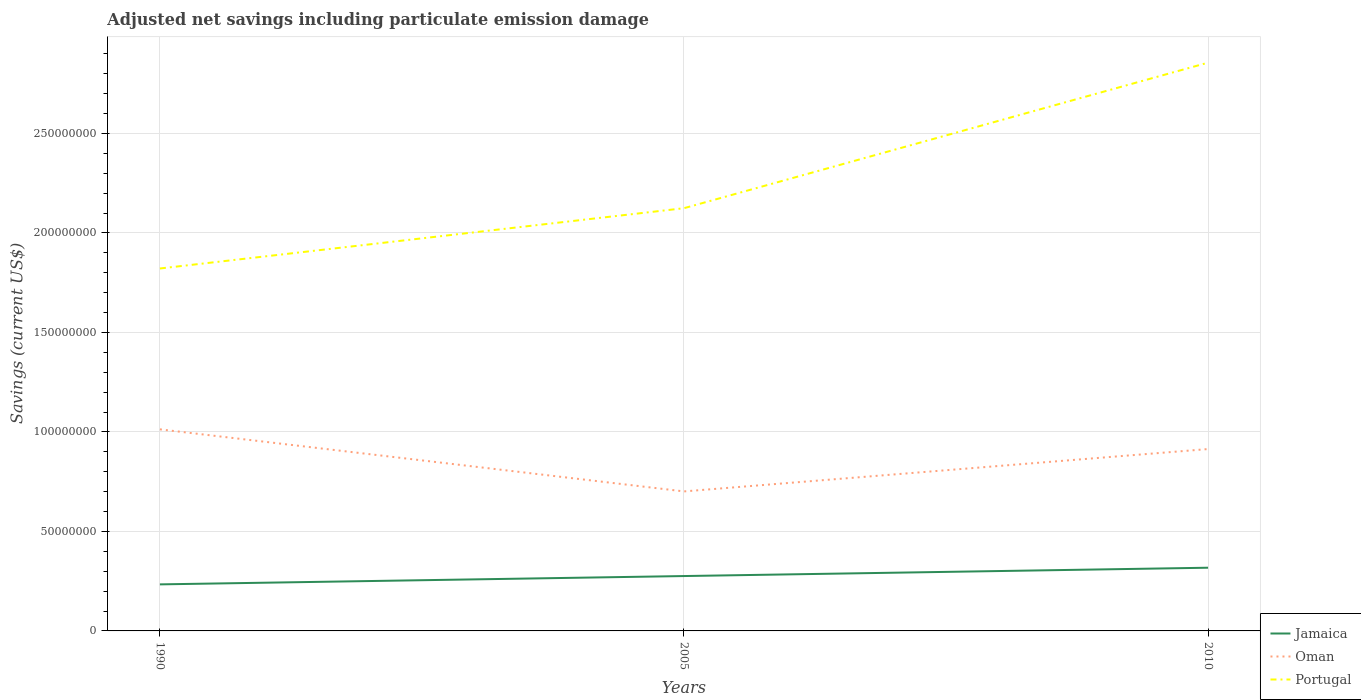Is the number of lines equal to the number of legend labels?
Make the answer very short. Yes. Across all years, what is the maximum net savings in Portugal?
Your response must be concise. 1.82e+08. What is the total net savings in Oman in the graph?
Offer a terse response. -2.13e+07. What is the difference between the highest and the second highest net savings in Jamaica?
Give a very brief answer. 8.37e+06. What is the difference between the highest and the lowest net savings in Jamaica?
Offer a terse response. 1. Is the net savings in Oman strictly greater than the net savings in Jamaica over the years?
Your response must be concise. No. How many lines are there?
Provide a succinct answer. 3. What is the difference between two consecutive major ticks on the Y-axis?
Your answer should be very brief. 5.00e+07. Are the values on the major ticks of Y-axis written in scientific E-notation?
Offer a very short reply. No. Does the graph contain grids?
Offer a terse response. Yes. How many legend labels are there?
Make the answer very short. 3. How are the legend labels stacked?
Your response must be concise. Vertical. What is the title of the graph?
Make the answer very short. Adjusted net savings including particulate emission damage. Does "Iraq" appear as one of the legend labels in the graph?
Your answer should be very brief. No. What is the label or title of the Y-axis?
Provide a short and direct response. Savings (current US$). What is the Savings (current US$) of Jamaica in 1990?
Ensure brevity in your answer.  2.34e+07. What is the Savings (current US$) in Oman in 1990?
Your answer should be very brief. 1.01e+08. What is the Savings (current US$) of Portugal in 1990?
Offer a very short reply. 1.82e+08. What is the Savings (current US$) in Jamaica in 2005?
Make the answer very short. 2.76e+07. What is the Savings (current US$) of Oman in 2005?
Offer a very short reply. 7.01e+07. What is the Savings (current US$) in Portugal in 2005?
Provide a succinct answer. 2.12e+08. What is the Savings (current US$) of Jamaica in 2010?
Give a very brief answer. 3.18e+07. What is the Savings (current US$) in Oman in 2010?
Make the answer very short. 9.14e+07. What is the Savings (current US$) in Portugal in 2010?
Your answer should be very brief. 2.86e+08. Across all years, what is the maximum Savings (current US$) in Jamaica?
Offer a terse response. 3.18e+07. Across all years, what is the maximum Savings (current US$) in Oman?
Your answer should be very brief. 1.01e+08. Across all years, what is the maximum Savings (current US$) of Portugal?
Your answer should be compact. 2.86e+08. Across all years, what is the minimum Savings (current US$) of Jamaica?
Offer a terse response. 2.34e+07. Across all years, what is the minimum Savings (current US$) in Oman?
Provide a succinct answer. 7.01e+07. Across all years, what is the minimum Savings (current US$) of Portugal?
Offer a very short reply. 1.82e+08. What is the total Savings (current US$) in Jamaica in the graph?
Provide a short and direct response. 8.27e+07. What is the total Savings (current US$) of Oman in the graph?
Provide a short and direct response. 2.63e+08. What is the total Savings (current US$) of Portugal in the graph?
Make the answer very short. 6.80e+08. What is the difference between the Savings (current US$) in Jamaica in 1990 and that in 2005?
Your response must be concise. -4.18e+06. What is the difference between the Savings (current US$) in Oman in 1990 and that in 2005?
Keep it short and to the point. 3.12e+07. What is the difference between the Savings (current US$) in Portugal in 1990 and that in 2005?
Your answer should be compact. -3.03e+07. What is the difference between the Savings (current US$) in Jamaica in 1990 and that in 2010?
Give a very brief answer. -8.37e+06. What is the difference between the Savings (current US$) of Oman in 1990 and that in 2010?
Your answer should be compact. 9.91e+06. What is the difference between the Savings (current US$) in Portugal in 1990 and that in 2010?
Give a very brief answer. -1.03e+08. What is the difference between the Savings (current US$) of Jamaica in 2005 and that in 2010?
Your response must be concise. -4.19e+06. What is the difference between the Savings (current US$) of Oman in 2005 and that in 2010?
Provide a short and direct response. -2.13e+07. What is the difference between the Savings (current US$) in Portugal in 2005 and that in 2010?
Provide a succinct answer. -7.31e+07. What is the difference between the Savings (current US$) of Jamaica in 1990 and the Savings (current US$) of Oman in 2005?
Keep it short and to the point. -4.67e+07. What is the difference between the Savings (current US$) of Jamaica in 1990 and the Savings (current US$) of Portugal in 2005?
Offer a very short reply. -1.89e+08. What is the difference between the Savings (current US$) in Oman in 1990 and the Savings (current US$) in Portugal in 2005?
Make the answer very short. -1.11e+08. What is the difference between the Savings (current US$) in Jamaica in 1990 and the Savings (current US$) in Oman in 2010?
Make the answer very short. -6.80e+07. What is the difference between the Savings (current US$) in Jamaica in 1990 and the Savings (current US$) in Portugal in 2010?
Your response must be concise. -2.62e+08. What is the difference between the Savings (current US$) of Oman in 1990 and the Savings (current US$) of Portugal in 2010?
Your answer should be very brief. -1.84e+08. What is the difference between the Savings (current US$) in Jamaica in 2005 and the Savings (current US$) in Oman in 2010?
Your answer should be very brief. -6.38e+07. What is the difference between the Savings (current US$) in Jamaica in 2005 and the Savings (current US$) in Portugal in 2010?
Make the answer very short. -2.58e+08. What is the difference between the Savings (current US$) of Oman in 2005 and the Savings (current US$) of Portugal in 2010?
Offer a terse response. -2.15e+08. What is the average Savings (current US$) of Jamaica per year?
Offer a terse response. 2.76e+07. What is the average Savings (current US$) of Oman per year?
Offer a terse response. 8.76e+07. What is the average Savings (current US$) in Portugal per year?
Provide a succinct answer. 2.27e+08. In the year 1990, what is the difference between the Savings (current US$) of Jamaica and Savings (current US$) of Oman?
Provide a succinct answer. -7.79e+07. In the year 1990, what is the difference between the Savings (current US$) in Jamaica and Savings (current US$) in Portugal?
Offer a very short reply. -1.59e+08. In the year 1990, what is the difference between the Savings (current US$) of Oman and Savings (current US$) of Portugal?
Keep it short and to the point. -8.08e+07. In the year 2005, what is the difference between the Savings (current US$) of Jamaica and Savings (current US$) of Oman?
Ensure brevity in your answer.  -4.25e+07. In the year 2005, what is the difference between the Savings (current US$) in Jamaica and Savings (current US$) in Portugal?
Your response must be concise. -1.85e+08. In the year 2005, what is the difference between the Savings (current US$) of Oman and Savings (current US$) of Portugal?
Provide a short and direct response. -1.42e+08. In the year 2010, what is the difference between the Savings (current US$) in Jamaica and Savings (current US$) in Oman?
Make the answer very short. -5.96e+07. In the year 2010, what is the difference between the Savings (current US$) of Jamaica and Savings (current US$) of Portugal?
Make the answer very short. -2.54e+08. In the year 2010, what is the difference between the Savings (current US$) in Oman and Savings (current US$) in Portugal?
Your answer should be very brief. -1.94e+08. What is the ratio of the Savings (current US$) of Jamaica in 1990 to that in 2005?
Give a very brief answer. 0.85. What is the ratio of the Savings (current US$) of Oman in 1990 to that in 2005?
Ensure brevity in your answer.  1.44. What is the ratio of the Savings (current US$) of Portugal in 1990 to that in 2005?
Ensure brevity in your answer.  0.86. What is the ratio of the Savings (current US$) in Jamaica in 1990 to that in 2010?
Provide a short and direct response. 0.74. What is the ratio of the Savings (current US$) of Oman in 1990 to that in 2010?
Give a very brief answer. 1.11. What is the ratio of the Savings (current US$) in Portugal in 1990 to that in 2010?
Your answer should be very brief. 0.64. What is the ratio of the Savings (current US$) of Jamaica in 2005 to that in 2010?
Keep it short and to the point. 0.87. What is the ratio of the Savings (current US$) of Oman in 2005 to that in 2010?
Provide a succinct answer. 0.77. What is the ratio of the Savings (current US$) of Portugal in 2005 to that in 2010?
Offer a terse response. 0.74. What is the difference between the highest and the second highest Savings (current US$) of Jamaica?
Your answer should be compact. 4.19e+06. What is the difference between the highest and the second highest Savings (current US$) in Oman?
Your answer should be very brief. 9.91e+06. What is the difference between the highest and the second highest Savings (current US$) in Portugal?
Provide a succinct answer. 7.31e+07. What is the difference between the highest and the lowest Savings (current US$) in Jamaica?
Provide a succinct answer. 8.37e+06. What is the difference between the highest and the lowest Savings (current US$) in Oman?
Make the answer very short. 3.12e+07. What is the difference between the highest and the lowest Savings (current US$) of Portugal?
Ensure brevity in your answer.  1.03e+08. 